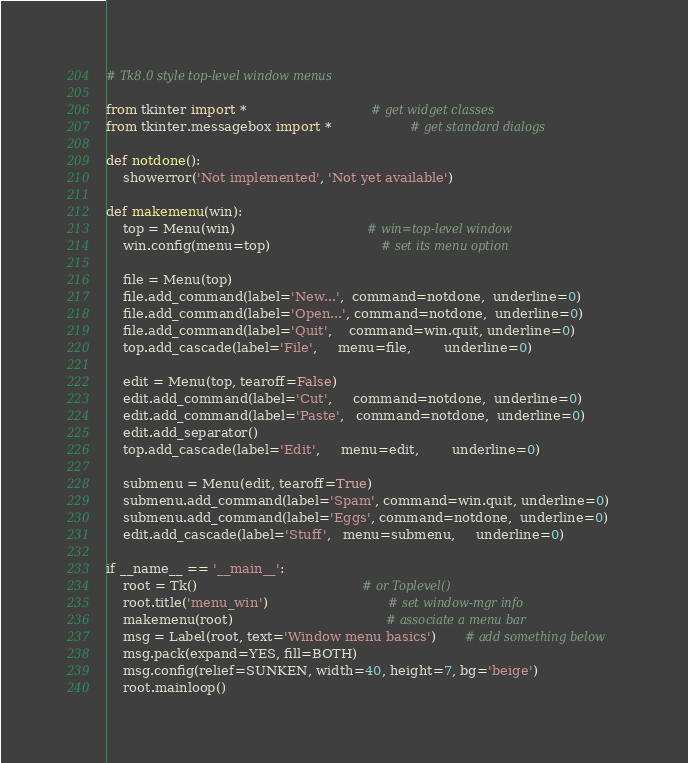Convert code to text. <code><loc_0><loc_0><loc_500><loc_500><_Python_># Tk8.0 style top-level window menus

from tkinter import *                              # get widget classes
from tkinter.messagebox import *                   # get standard dialogs

def notdone():
    showerror('Not implemented', 'Not yet available')

def makemenu(win):
    top = Menu(win)                                # win=top-level window
    win.config(menu=top)                           # set its menu option

    file = Menu(top)
    file.add_command(label='New...',  command=notdone,  underline=0)
    file.add_command(label='Open...', command=notdone,  underline=0)
    file.add_command(label='Quit',    command=win.quit, underline=0)
    top.add_cascade(label='File',     menu=file,        underline=0)

    edit = Menu(top, tearoff=False)
    edit.add_command(label='Cut',     command=notdone,  underline=0)
    edit.add_command(label='Paste',   command=notdone,  underline=0)
    edit.add_separator()
    top.add_cascade(label='Edit',     menu=edit,        underline=0)

    submenu = Menu(edit, tearoff=True)
    submenu.add_command(label='Spam', command=win.quit, underline=0)
    submenu.add_command(label='Eggs', command=notdone,  underline=0)
    edit.add_cascade(label='Stuff',   menu=submenu,     underline=0)

if __name__ == '__main__':
    root = Tk()                                        # or Toplevel()
    root.title('menu_win')                             # set window-mgr info
    makemenu(root)                                     # associate a menu bar
    msg = Label(root, text='Window menu basics')       # add something below
    msg.pack(expand=YES, fill=BOTH)
    msg.config(relief=SUNKEN, width=40, height=7, bg='beige')
    root.mainloop()
</code> 